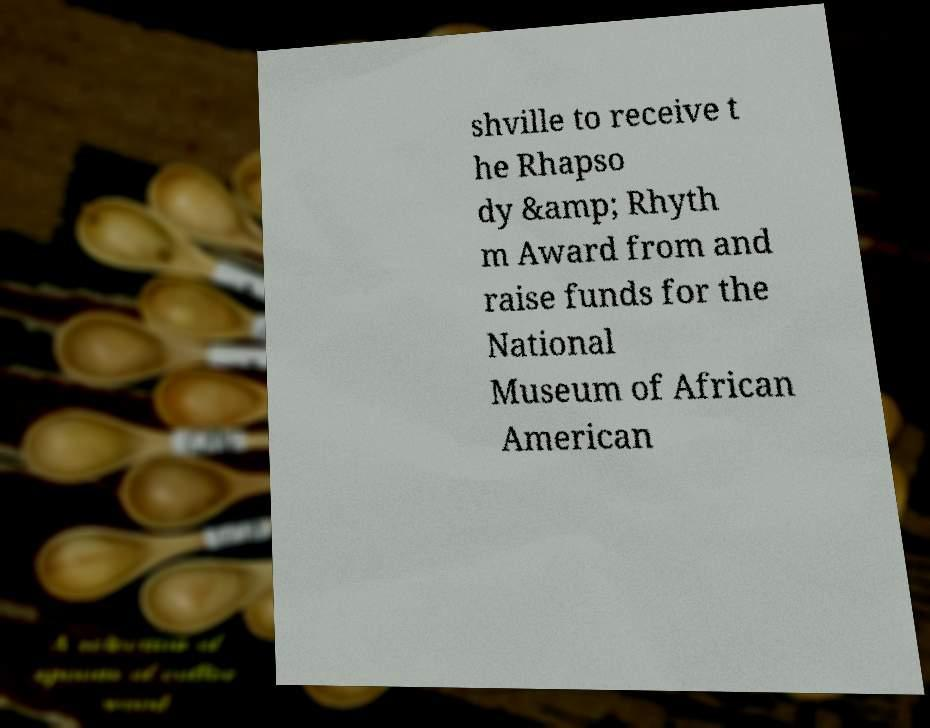Could you extract and type out the text from this image? shville to receive t he Rhapso dy &amp; Rhyth m Award from and raise funds for the National Museum of African American 